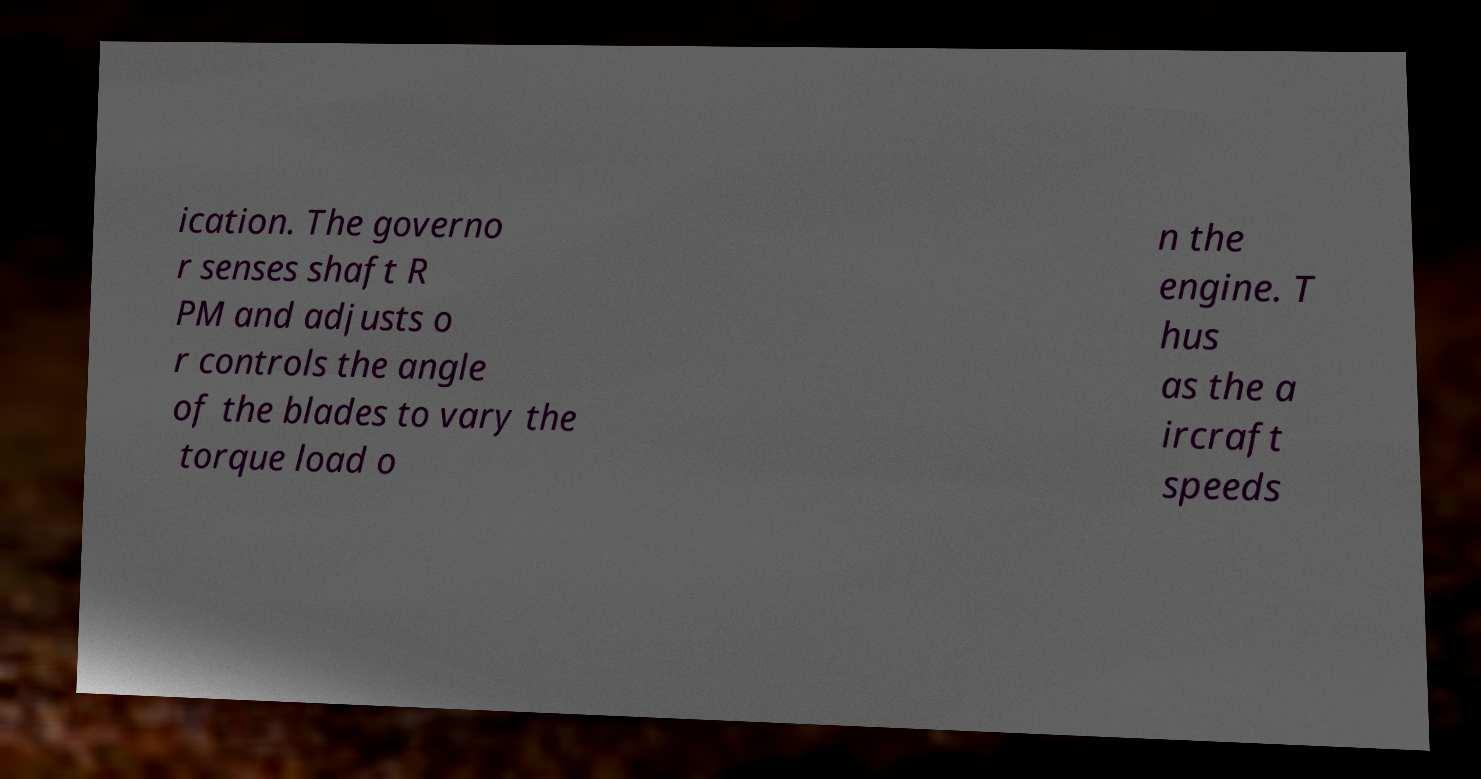Could you extract and type out the text from this image? ication. The governo r senses shaft R PM and adjusts o r controls the angle of the blades to vary the torque load o n the engine. T hus as the a ircraft speeds 